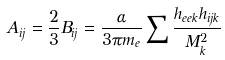Convert formula to latex. <formula><loc_0><loc_0><loc_500><loc_500>A _ { i j } = \frac { 2 } { 3 } B _ { i j } = \frac { \alpha } { 3 \pi m _ { e } } \sum \frac { h _ { e e k } h _ { i j k } } { M _ { k } ^ { 2 } }</formula> 